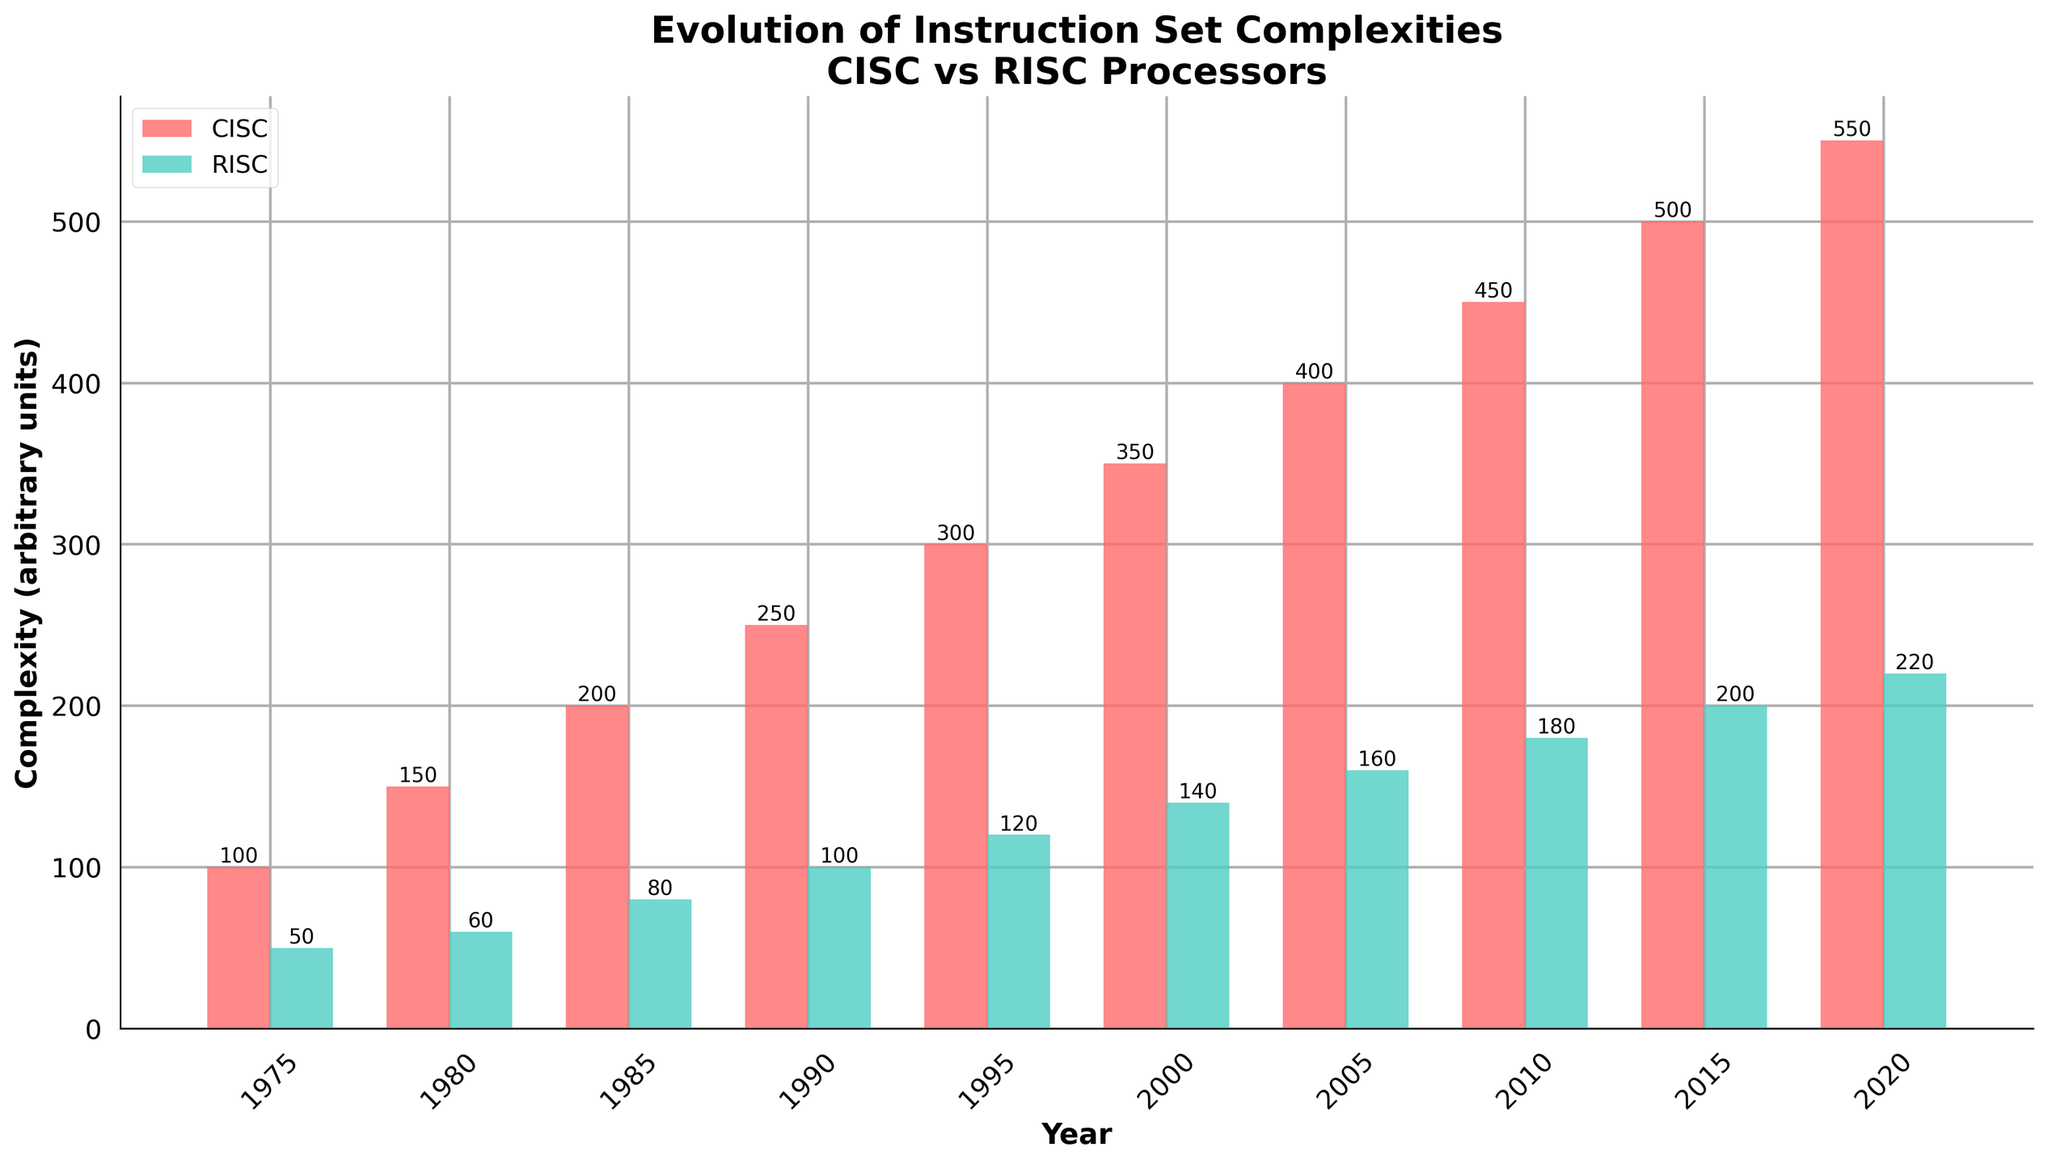Which type of processor had the higher complexity in 1985? By referring to the figure, the complexity of CISC and RISC processors in 1985 can be compared. The bar representing CISC complexity is taller than the bar representing RISC complexity.
Answer: CISC In which year did the difference in complexity between CISC and RISC processors reach 300 units? By examining the figure, we see that the difference in complexity between CISC and RISC processors reaches 300 units in 2000. The bars for CISC and RISC show values of 350 and 50 respectively, where 350 - 50 = 300.
Answer: 2000 What is the trend in complexity for both RISC and CISC processors from 1975 to 2020? By looking at the heights of the bars across different years, we can observe that both RISC and CISC processor complexities increased steadily over the years from 1975 to 2020.
Answer: Increasing What was the complexity of the Intel Core i7 (Nehalem) and how does it compare to the ARM Cortex-A9 in 2010? In 2010, Intel Core i7 (Nehalem)’s CISC complexity is 450 and ARM Cortex-A9’s RISC complexity is 180. Comparing these values, the CISC processor has a higher complexity.
Answer: 450, greater Calculate the average complexity of RISC processors over the decades shown in the figure. Sum the complexities for RISC processors in all years shown and divide by the number of years: (50 + 60 + 80 + 100 + 120 + 140 + 160 + 180 + 200 + 220) / 10. This sum equals 1310, and dividing by 10 gives an average complexity of 131.
Answer: 131 In which decade did both CISC and RISC processors see the smallest complexity growth? By visually comparing the heights of the bars between consecutive decades, we notice that the smallest growth in complexity for both processors is from 2010 to 2015, where the increase was 50 units for CISC and 20 units for RISC.
Answer: 2010s What can you infer about the complexity difference between CISC and RISC processors over the decades? Observing the plot, we see that the complexity difference between CISC and RISC processors increases over time. The gap between the bars grows larger from 1975 to 2020.
Answer: Increasing Identify the notable RISC processor in 1995 and compare its complexity to the notable CISC processor in the same year. The notable RISC processor in 1995 is PowerPC 601 with a complexity of 120, while the notable CISC processor is Intel Pentium with a complexity of 300. Therefore, the CISC processor has a higher complexity.
Answer: PowerPC 601, higher What is the color representation for RISC processors in the chart? By looking at the figure, the bars representing RISC processors are colored green.
Answer: Green Which processor type has the highest complexity overall, and in which year did this occur? By examining the chart, we see that the highest complexity is for CISC processors at 550 units, which occurred in 2020.
Answer: CISC, 2020 